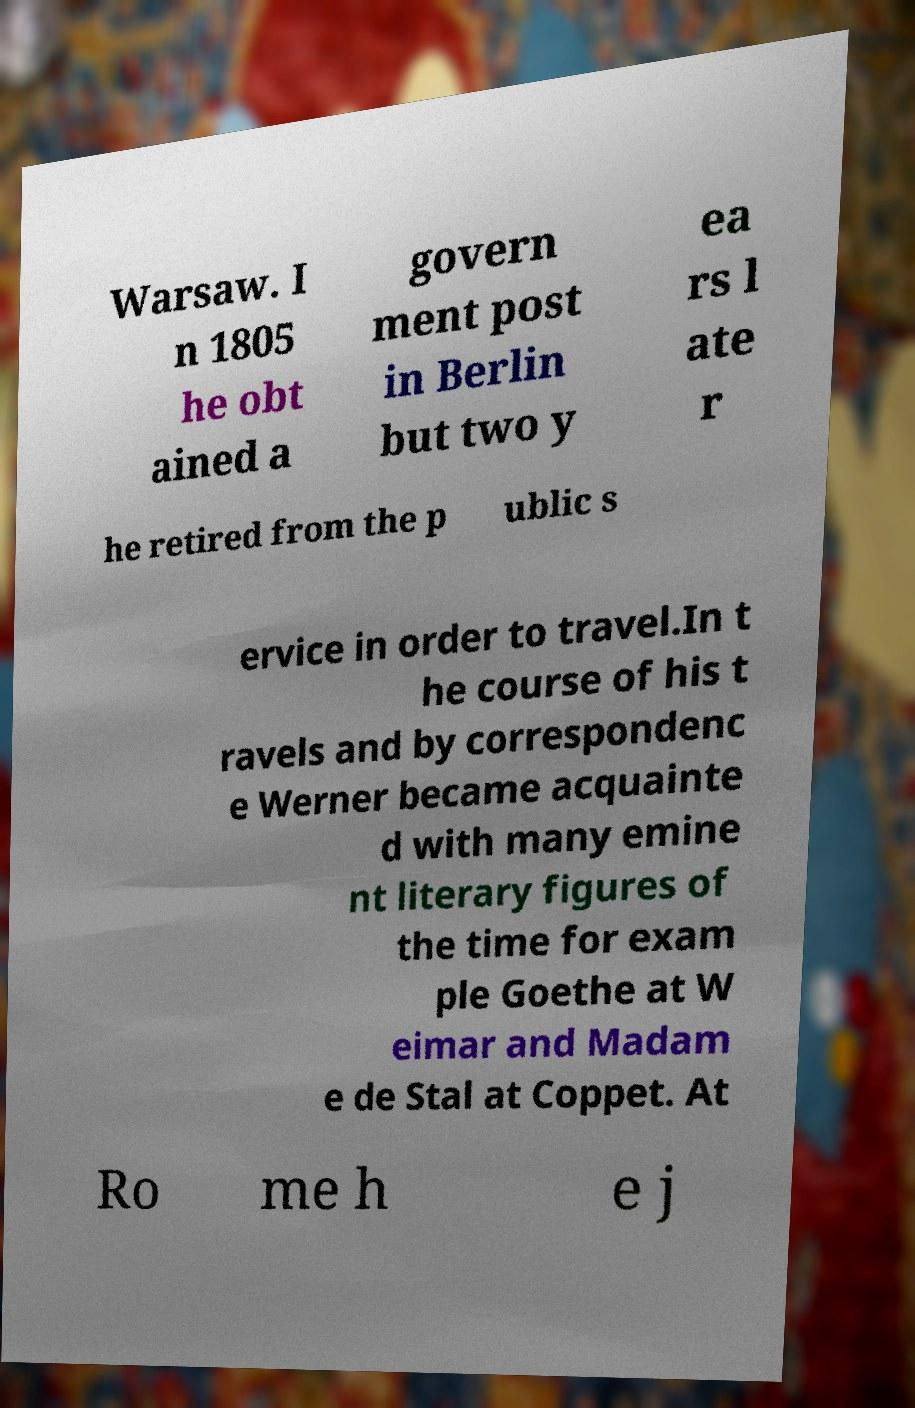What messages or text are displayed in this image? I need them in a readable, typed format. Warsaw. I n 1805 he obt ained a govern ment post in Berlin but two y ea rs l ate r he retired from the p ublic s ervice in order to travel.In t he course of his t ravels and by correspondenc e Werner became acquainte d with many emine nt literary figures of the time for exam ple Goethe at W eimar and Madam e de Stal at Coppet. At Ro me h e j 